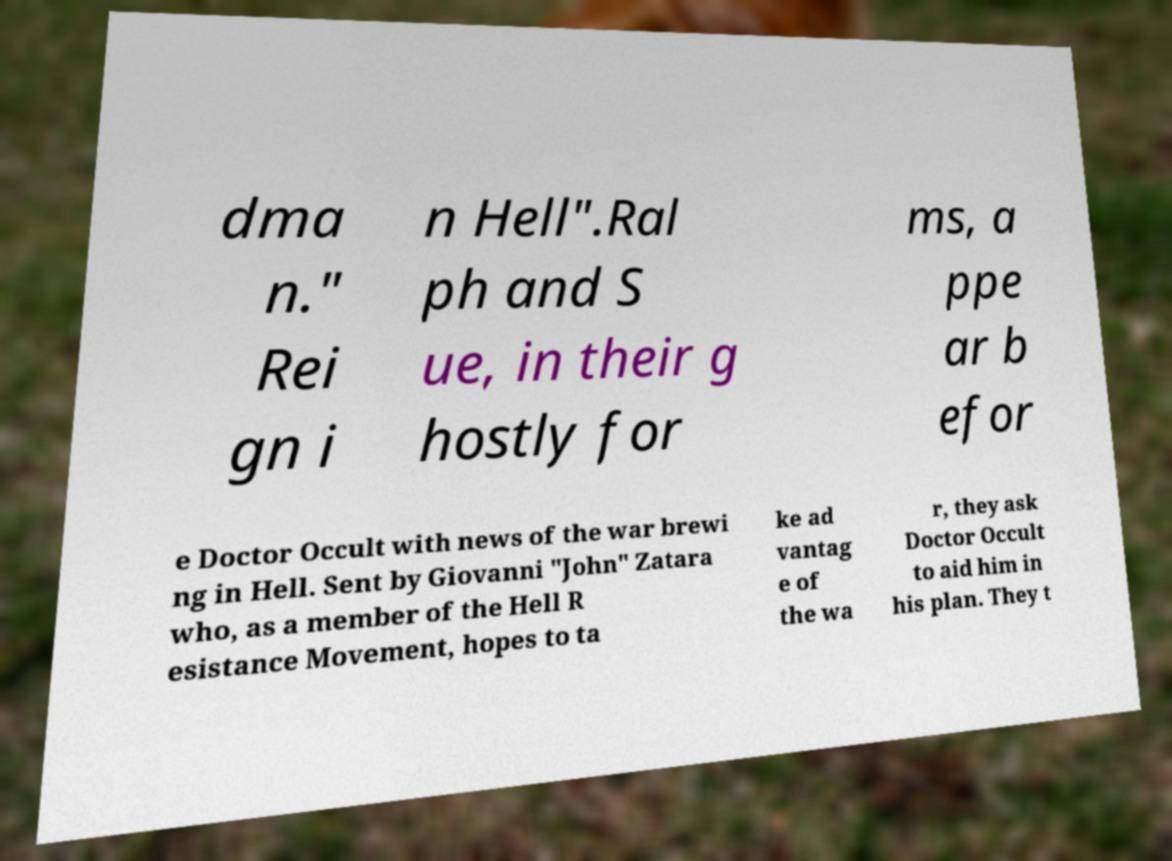What messages or text are displayed in this image? I need them in a readable, typed format. dma n." Rei gn i n Hell".Ral ph and S ue, in their g hostly for ms, a ppe ar b efor e Doctor Occult with news of the war brewi ng in Hell. Sent by Giovanni "John" Zatara who, as a member of the Hell R esistance Movement, hopes to ta ke ad vantag e of the wa r, they ask Doctor Occult to aid him in his plan. They t 